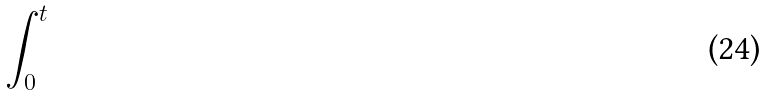<formula> <loc_0><loc_0><loc_500><loc_500>\int _ { 0 } ^ { t }</formula> 